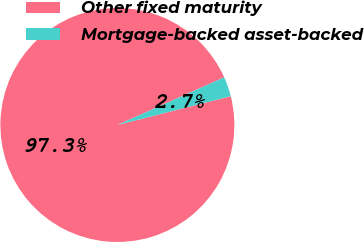<chart> <loc_0><loc_0><loc_500><loc_500><pie_chart><fcel>Other fixed maturity<fcel>Mortgage-backed asset-backed<nl><fcel>97.28%<fcel>2.72%<nl></chart> 